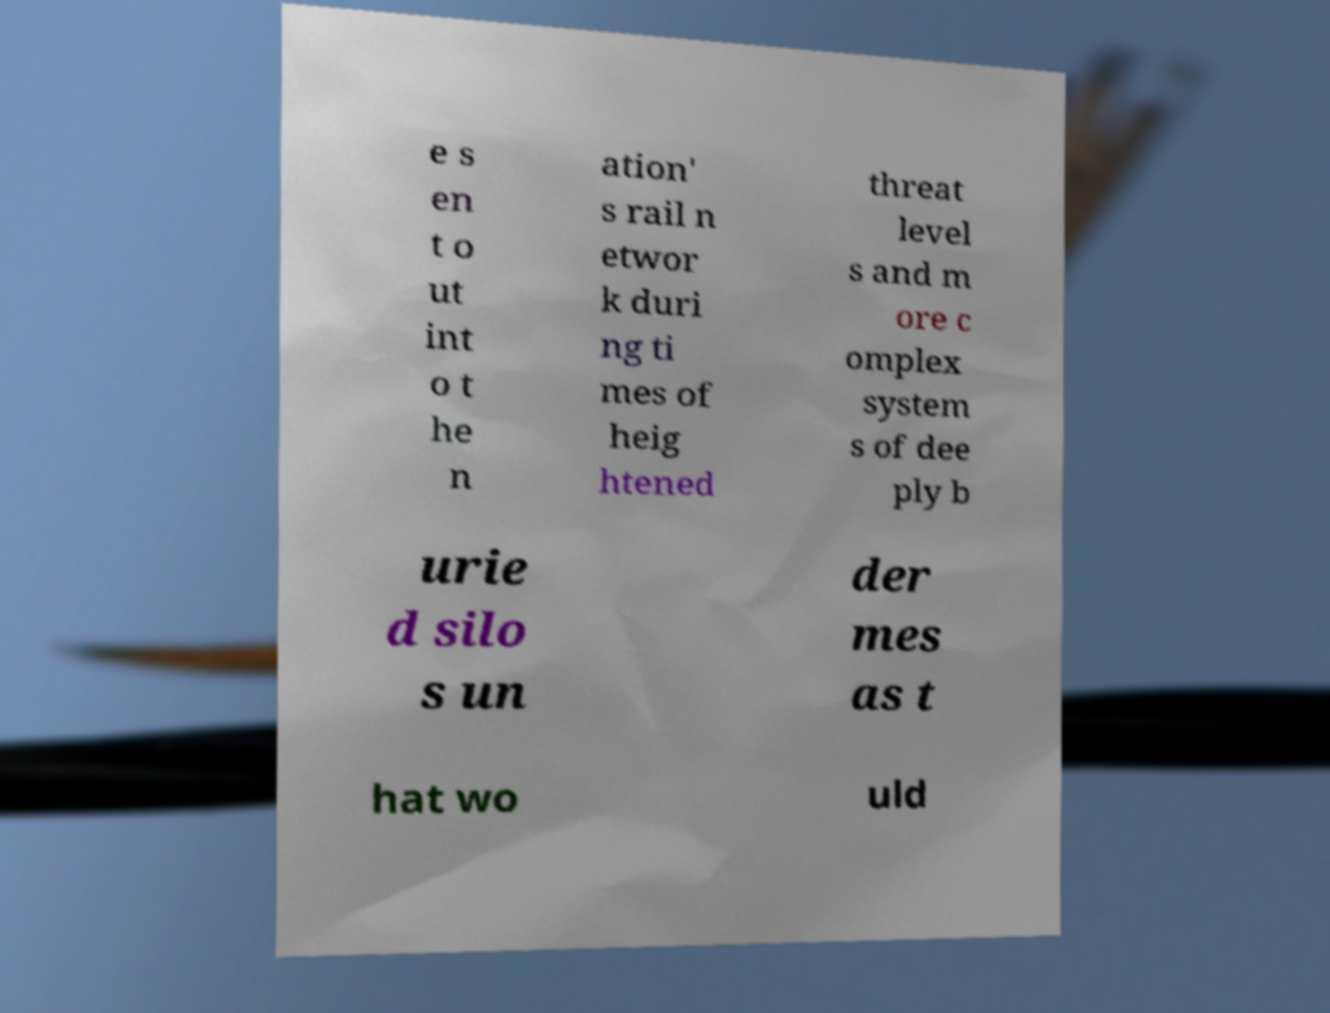For documentation purposes, I need the text within this image transcribed. Could you provide that? e s en t o ut int o t he n ation' s rail n etwor k duri ng ti mes of heig htened threat level s and m ore c omplex system s of dee ply b urie d silo s un der mes as t hat wo uld 